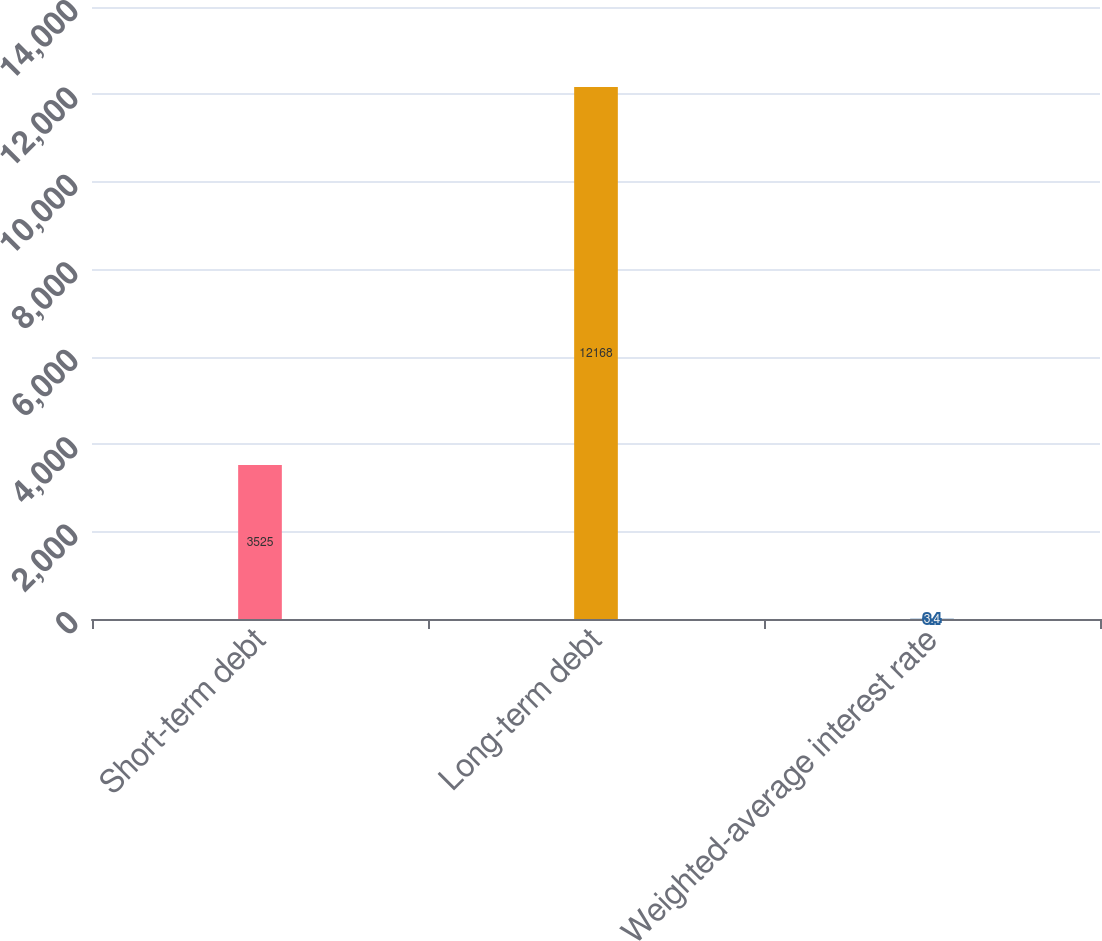Convert chart. <chart><loc_0><loc_0><loc_500><loc_500><bar_chart><fcel>Short-term debt<fcel>Long-term debt<fcel>Weighted-average interest rate<nl><fcel>3525<fcel>12168<fcel>3.4<nl></chart> 